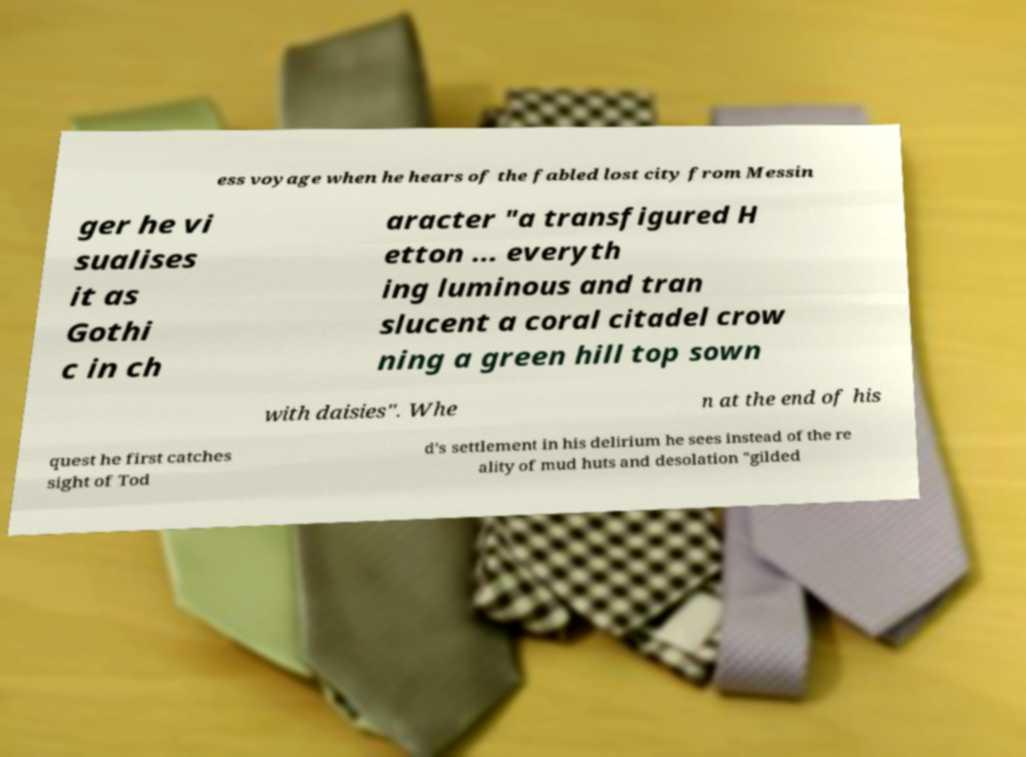For documentation purposes, I need the text within this image transcribed. Could you provide that? ess voyage when he hears of the fabled lost city from Messin ger he vi sualises it as Gothi c in ch aracter "a transfigured H etton ... everyth ing luminous and tran slucent a coral citadel crow ning a green hill top sown with daisies". Whe n at the end of his quest he first catches sight of Tod d's settlement in his delirium he sees instead of the re ality of mud huts and desolation "gilded 